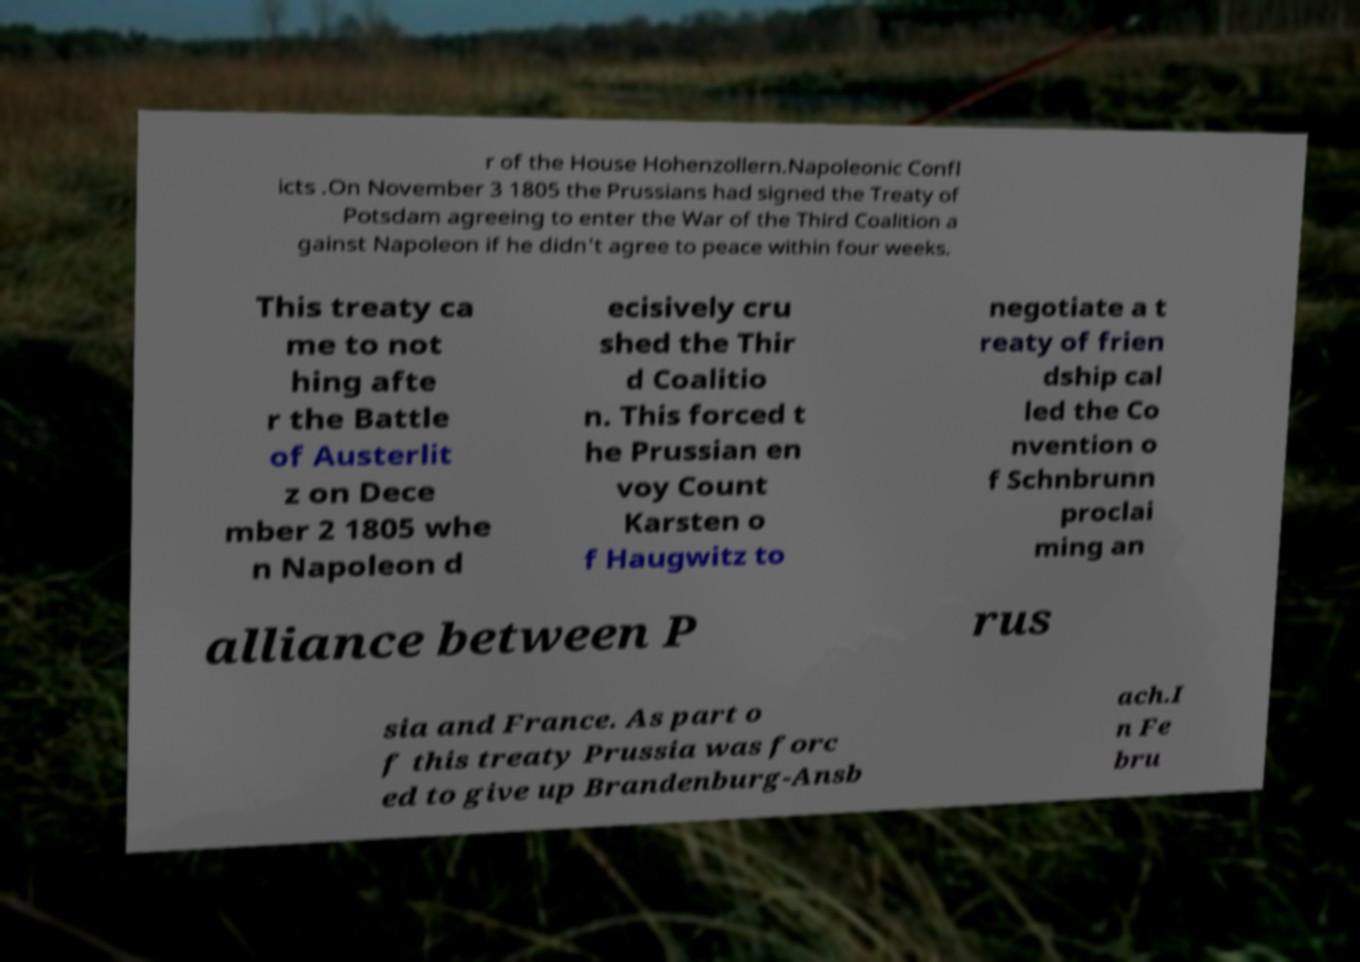Can you read and provide the text displayed in the image?This photo seems to have some interesting text. Can you extract and type it out for me? r of the House Hohenzollern.Napoleonic Confl icts .On November 3 1805 the Prussians had signed the Treaty of Potsdam agreeing to enter the War of the Third Coalition a gainst Napoleon if he didn't agree to peace within four weeks. This treaty ca me to not hing afte r the Battle of Austerlit z on Dece mber 2 1805 whe n Napoleon d ecisively cru shed the Thir d Coalitio n. This forced t he Prussian en voy Count Karsten o f Haugwitz to negotiate a t reaty of frien dship cal led the Co nvention o f Schnbrunn proclai ming an alliance between P rus sia and France. As part o f this treaty Prussia was forc ed to give up Brandenburg-Ansb ach.I n Fe bru 